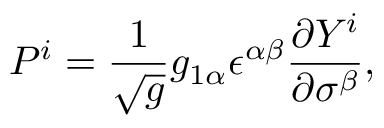Convert formula to latex. <formula><loc_0><loc_0><loc_500><loc_500>P ^ { i } = \frac { 1 } { \sqrt { g } } g _ { 1 \alpha } \epsilon ^ { \alpha \beta } \frac { \partial Y ^ { i } } { \partial \sigma ^ { \beta } } ,</formula> 